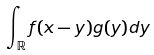<formula> <loc_0><loc_0><loc_500><loc_500>\int _ { \mathbb { R } } f ( x - y ) g ( y ) d y</formula> 